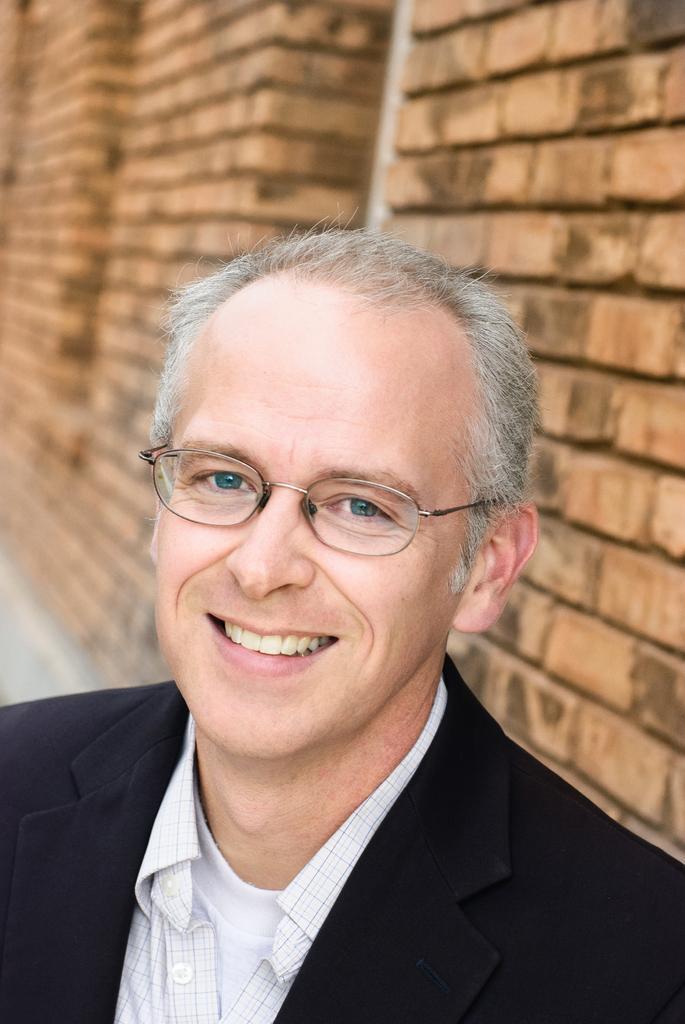Could you give a brief overview of what you see in this image? In this picture there is a person wearing black suit is smiling and there is a brick wall behind him. 